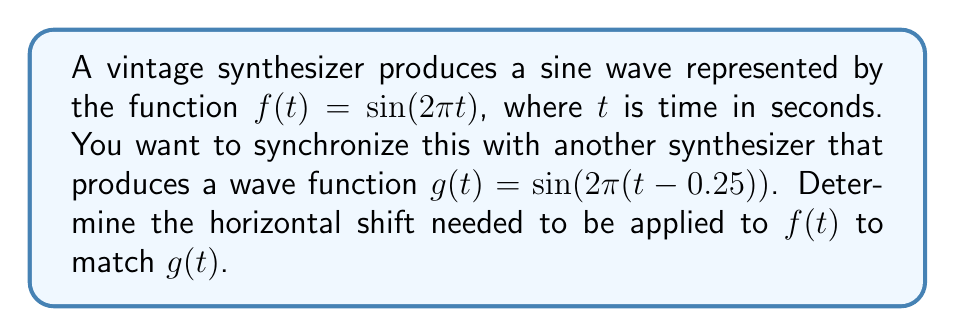Can you answer this question? 1) The general form of a horizontally shifted sine function is:
   $h(t) = \sin(2\pi(t - c))$, where $c$ is the horizontal shift.

2) We're given $g(t) = \sin(2\pi(t - 0.25))$, which is already in this form.

3) Comparing $g(t)$ to the general form, we can see that $c = 0.25$.

4) This means $g(t)$ is shifted 0.25 units to the right compared to the standard sine function.

5) To make $f(t)$ match $g(t)$, we need to apply the same shift to $f(t)$.

6) Therefore, we need to shift $f(t)$ to the right by 0.25 units.

7) The resulting function would be:
   $f_{shifted}(t) = \sin(2\pi(t - 0.25))$

8) In terms of the synthesizer output, this means delaying the output of the first synthesizer by 0.25 seconds.
Answer: 0.25 units right (or 0.25 seconds delay) 